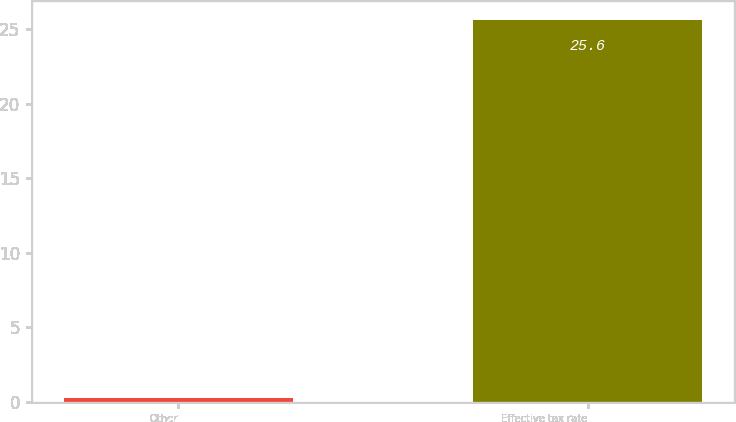<chart> <loc_0><loc_0><loc_500><loc_500><bar_chart><fcel>Other<fcel>Effective tax rate<nl><fcel>0.3<fcel>25.6<nl></chart> 